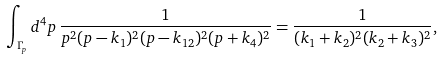Convert formula to latex. <formula><loc_0><loc_0><loc_500><loc_500>\int _ { \Gamma _ { p } } d ^ { 4 } p \, \frac { 1 } { p ^ { 2 } ( p - k _ { 1 } ) ^ { 2 } ( p - k _ { 1 2 } ) ^ { 2 } ( p + k _ { 4 } ) ^ { 2 } } = \frac { 1 } { ( k _ { 1 } + k _ { 2 } ) ^ { 2 } ( k _ { 2 } + k _ { 3 } ) ^ { 2 } } ,</formula> 